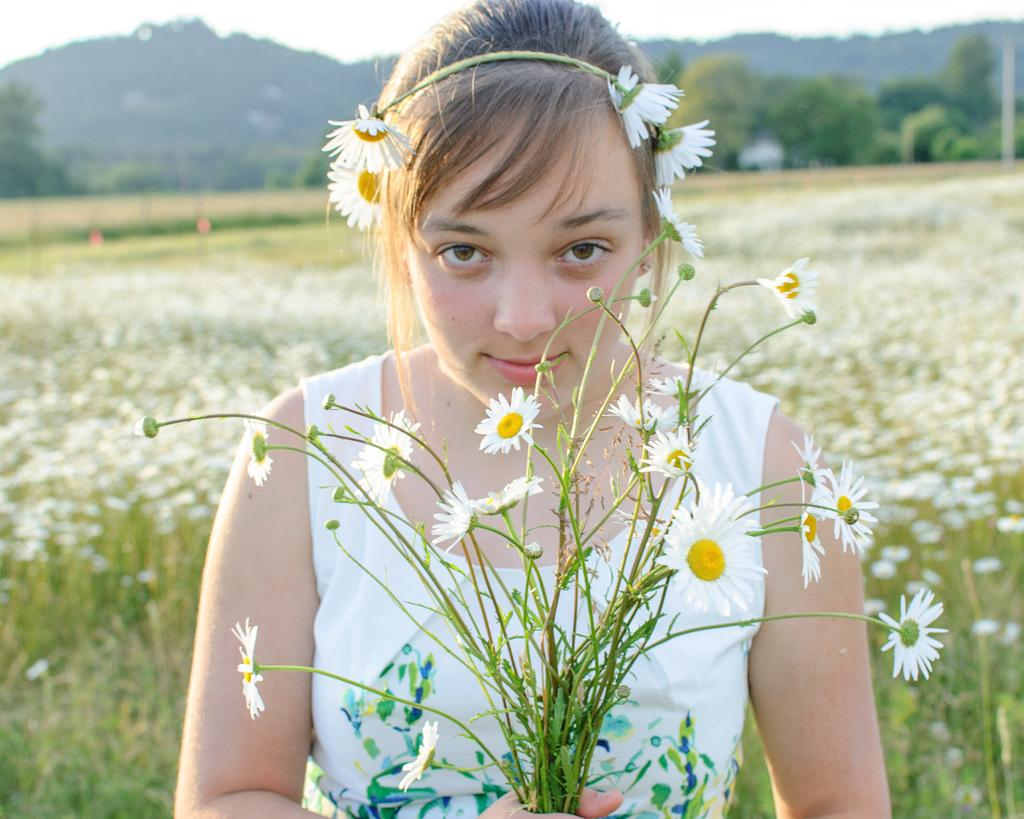Who is the main subject in the image? There is a girl in the image. Where is the girl located in relation to the image? The girl is in the foreground. What is the girl holding in the image? The girl is holding flowers. How is the background of the girl depicted in the image? The background of the girl is blurred. What type of sock is the girl wearing in the image? There is no information about the girl's socks in the image, so we cannot determine if she is wearing any. 